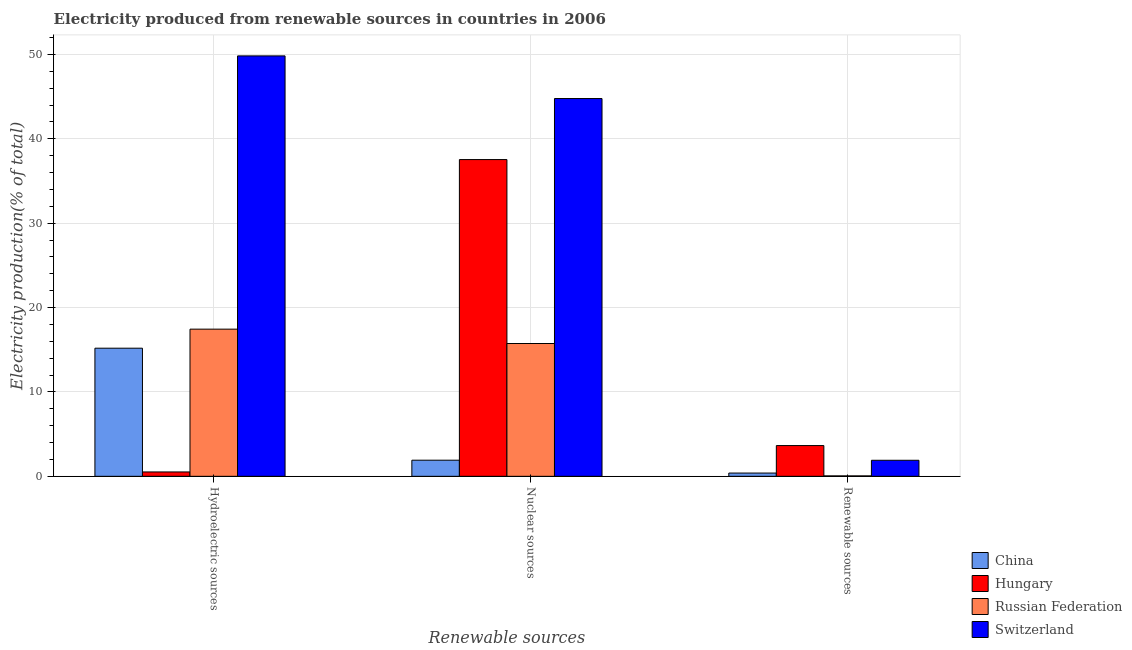How many groups of bars are there?
Keep it short and to the point. 3. Are the number of bars per tick equal to the number of legend labels?
Give a very brief answer. Yes. Are the number of bars on each tick of the X-axis equal?
Provide a short and direct response. Yes. How many bars are there on the 1st tick from the left?
Ensure brevity in your answer.  4. How many bars are there on the 3rd tick from the right?
Provide a succinct answer. 4. What is the label of the 1st group of bars from the left?
Give a very brief answer. Hydroelectric sources. What is the percentage of electricity produced by nuclear sources in Russian Federation?
Your answer should be very brief. 15.74. Across all countries, what is the maximum percentage of electricity produced by renewable sources?
Your answer should be very brief. 3.64. Across all countries, what is the minimum percentage of electricity produced by nuclear sources?
Keep it short and to the point. 1.91. In which country was the percentage of electricity produced by hydroelectric sources maximum?
Keep it short and to the point. Switzerland. In which country was the percentage of electricity produced by renewable sources minimum?
Make the answer very short. Russian Federation. What is the total percentage of electricity produced by nuclear sources in the graph?
Provide a succinct answer. 99.96. What is the difference between the percentage of electricity produced by renewable sources in Hungary and that in Russian Federation?
Provide a succinct answer. 3.59. What is the difference between the percentage of electricity produced by hydroelectric sources in Switzerland and the percentage of electricity produced by nuclear sources in Russian Federation?
Offer a very short reply. 34.09. What is the average percentage of electricity produced by hydroelectric sources per country?
Keep it short and to the point. 20.74. What is the difference between the percentage of electricity produced by nuclear sources and percentage of electricity produced by renewable sources in Hungary?
Make the answer very short. 33.89. In how many countries, is the percentage of electricity produced by renewable sources greater than 6 %?
Your answer should be compact. 0. What is the ratio of the percentage of electricity produced by renewable sources in Switzerland to that in China?
Your answer should be compact. 4.91. Is the percentage of electricity produced by nuclear sources in Switzerland less than that in Hungary?
Make the answer very short. No. What is the difference between the highest and the second highest percentage of electricity produced by hydroelectric sources?
Ensure brevity in your answer.  32.38. What is the difference between the highest and the lowest percentage of electricity produced by nuclear sources?
Ensure brevity in your answer.  42.86. In how many countries, is the percentage of electricity produced by renewable sources greater than the average percentage of electricity produced by renewable sources taken over all countries?
Provide a succinct answer. 2. What does the 2nd bar from the left in Nuclear sources represents?
Make the answer very short. Hungary. What does the 2nd bar from the right in Renewable sources represents?
Provide a succinct answer. Russian Federation. How many bars are there?
Offer a terse response. 12. Are all the bars in the graph horizontal?
Offer a very short reply. No. How many countries are there in the graph?
Provide a succinct answer. 4. What is the difference between two consecutive major ticks on the Y-axis?
Offer a very short reply. 10. Does the graph contain any zero values?
Make the answer very short. No. Does the graph contain grids?
Offer a very short reply. Yes. Where does the legend appear in the graph?
Keep it short and to the point. Bottom right. How many legend labels are there?
Make the answer very short. 4. How are the legend labels stacked?
Your answer should be very brief. Vertical. What is the title of the graph?
Your answer should be very brief. Electricity produced from renewable sources in countries in 2006. Does "Kuwait" appear as one of the legend labels in the graph?
Offer a terse response. No. What is the label or title of the X-axis?
Ensure brevity in your answer.  Renewable sources. What is the label or title of the Y-axis?
Give a very brief answer. Electricity production(% of total). What is the Electricity production(% of total) of China in Hydroelectric sources?
Ensure brevity in your answer.  15.19. What is the Electricity production(% of total) in Hungary in Hydroelectric sources?
Offer a very short reply. 0.52. What is the Electricity production(% of total) of Russian Federation in Hydroelectric sources?
Offer a very short reply. 17.44. What is the Electricity production(% of total) in Switzerland in Hydroelectric sources?
Keep it short and to the point. 49.83. What is the Electricity production(% of total) of China in Nuclear sources?
Your answer should be compact. 1.91. What is the Electricity production(% of total) of Hungary in Nuclear sources?
Offer a terse response. 37.54. What is the Electricity production(% of total) in Russian Federation in Nuclear sources?
Offer a very short reply. 15.74. What is the Electricity production(% of total) in Switzerland in Nuclear sources?
Give a very brief answer. 44.77. What is the Electricity production(% of total) of China in Renewable sources?
Give a very brief answer. 0.39. What is the Electricity production(% of total) in Hungary in Renewable sources?
Make the answer very short. 3.64. What is the Electricity production(% of total) of Russian Federation in Renewable sources?
Keep it short and to the point. 0.05. What is the Electricity production(% of total) in Switzerland in Renewable sources?
Provide a short and direct response. 1.9. Across all Renewable sources, what is the maximum Electricity production(% of total) of China?
Provide a succinct answer. 15.19. Across all Renewable sources, what is the maximum Electricity production(% of total) of Hungary?
Ensure brevity in your answer.  37.54. Across all Renewable sources, what is the maximum Electricity production(% of total) of Russian Federation?
Your answer should be very brief. 17.44. Across all Renewable sources, what is the maximum Electricity production(% of total) of Switzerland?
Your answer should be very brief. 49.83. Across all Renewable sources, what is the minimum Electricity production(% of total) of China?
Make the answer very short. 0.39. Across all Renewable sources, what is the minimum Electricity production(% of total) in Hungary?
Ensure brevity in your answer.  0.52. Across all Renewable sources, what is the minimum Electricity production(% of total) of Russian Federation?
Provide a succinct answer. 0.05. Across all Renewable sources, what is the minimum Electricity production(% of total) of Switzerland?
Your answer should be compact. 1.9. What is the total Electricity production(% of total) of China in the graph?
Your answer should be very brief. 17.48. What is the total Electricity production(% of total) of Hungary in the graph?
Offer a terse response. 41.7. What is the total Electricity production(% of total) in Russian Federation in the graph?
Offer a very short reply. 33.23. What is the total Electricity production(% of total) of Switzerland in the graph?
Provide a succinct answer. 96.5. What is the difference between the Electricity production(% of total) in China in Hydroelectric sources and that in Nuclear sources?
Offer a terse response. 13.27. What is the difference between the Electricity production(% of total) in Hungary in Hydroelectric sources and that in Nuclear sources?
Ensure brevity in your answer.  -37.02. What is the difference between the Electricity production(% of total) of Russian Federation in Hydroelectric sources and that in Nuclear sources?
Your answer should be very brief. 1.7. What is the difference between the Electricity production(% of total) in Switzerland in Hydroelectric sources and that in Nuclear sources?
Offer a very short reply. 5.05. What is the difference between the Electricity production(% of total) in China in Hydroelectric sources and that in Renewable sources?
Offer a terse response. 14.8. What is the difference between the Electricity production(% of total) of Hungary in Hydroelectric sources and that in Renewable sources?
Offer a terse response. -3.13. What is the difference between the Electricity production(% of total) in Russian Federation in Hydroelectric sources and that in Renewable sources?
Offer a very short reply. 17.39. What is the difference between the Electricity production(% of total) of Switzerland in Hydroelectric sources and that in Renewable sources?
Your answer should be very brief. 47.92. What is the difference between the Electricity production(% of total) in China in Nuclear sources and that in Renewable sources?
Provide a succinct answer. 1.52. What is the difference between the Electricity production(% of total) of Hungary in Nuclear sources and that in Renewable sources?
Give a very brief answer. 33.89. What is the difference between the Electricity production(% of total) in Russian Federation in Nuclear sources and that in Renewable sources?
Offer a terse response. 15.69. What is the difference between the Electricity production(% of total) of Switzerland in Nuclear sources and that in Renewable sources?
Offer a terse response. 42.87. What is the difference between the Electricity production(% of total) in China in Hydroelectric sources and the Electricity production(% of total) in Hungary in Nuclear sources?
Your answer should be very brief. -22.35. What is the difference between the Electricity production(% of total) of China in Hydroelectric sources and the Electricity production(% of total) of Russian Federation in Nuclear sources?
Keep it short and to the point. -0.56. What is the difference between the Electricity production(% of total) of China in Hydroelectric sources and the Electricity production(% of total) of Switzerland in Nuclear sources?
Provide a short and direct response. -29.59. What is the difference between the Electricity production(% of total) in Hungary in Hydroelectric sources and the Electricity production(% of total) in Russian Federation in Nuclear sources?
Your response must be concise. -15.22. What is the difference between the Electricity production(% of total) of Hungary in Hydroelectric sources and the Electricity production(% of total) of Switzerland in Nuclear sources?
Keep it short and to the point. -44.25. What is the difference between the Electricity production(% of total) in Russian Federation in Hydroelectric sources and the Electricity production(% of total) in Switzerland in Nuclear sources?
Ensure brevity in your answer.  -27.33. What is the difference between the Electricity production(% of total) in China in Hydroelectric sources and the Electricity production(% of total) in Hungary in Renewable sources?
Offer a very short reply. 11.54. What is the difference between the Electricity production(% of total) of China in Hydroelectric sources and the Electricity production(% of total) of Russian Federation in Renewable sources?
Keep it short and to the point. 15.13. What is the difference between the Electricity production(% of total) of China in Hydroelectric sources and the Electricity production(% of total) of Switzerland in Renewable sources?
Offer a very short reply. 13.28. What is the difference between the Electricity production(% of total) of Hungary in Hydroelectric sources and the Electricity production(% of total) of Russian Federation in Renewable sources?
Provide a succinct answer. 0.47. What is the difference between the Electricity production(% of total) of Hungary in Hydroelectric sources and the Electricity production(% of total) of Switzerland in Renewable sources?
Offer a terse response. -1.38. What is the difference between the Electricity production(% of total) of Russian Federation in Hydroelectric sources and the Electricity production(% of total) of Switzerland in Renewable sources?
Keep it short and to the point. 15.54. What is the difference between the Electricity production(% of total) in China in Nuclear sources and the Electricity production(% of total) in Hungary in Renewable sources?
Provide a succinct answer. -1.73. What is the difference between the Electricity production(% of total) in China in Nuclear sources and the Electricity production(% of total) in Russian Federation in Renewable sources?
Offer a very short reply. 1.86. What is the difference between the Electricity production(% of total) in China in Nuclear sources and the Electricity production(% of total) in Switzerland in Renewable sources?
Your answer should be compact. 0.01. What is the difference between the Electricity production(% of total) of Hungary in Nuclear sources and the Electricity production(% of total) of Russian Federation in Renewable sources?
Keep it short and to the point. 37.49. What is the difference between the Electricity production(% of total) of Hungary in Nuclear sources and the Electricity production(% of total) of Switzerland in Renewable sources?
Offer a very short reply. 35.64. What is the difference between the Electricity production(% of total) of Russian Federation in Nuclear sources and the Electricity production(% of total) of Switzerland in Renewable sources?
Your answer should be compact. 13.84. What is the average Electricity production(% of total) of China per Renewable sources?
Provide a succinct answer. 5.83. What is the average Electricity production(% of total) of Hungary per Renewable sources?
Provide a short and direct response. 13.9. What is the average Electricity production(% of total) of Russian Federation per Renewable sources?
Offer a terse response. 11.08. What is the average Electricity production(% of total) of Switzerland per Renewable sources?
Offer a terse response. 32.17. What is the difference between the Electricity production(% of total) in China and Electricity production(% of total) in Hungary in Hydroelectric sources?
Make the answer very short. 14.67. What is the difference between the Electricity production(% of total) in China and Electricity production(% of total) in Russian Federation in Hydroelectric sources?
Provide a succinct answer. -2.26. What is the difference between the Electricity production(% of total) in China and Electricity production(% of total) in Switzerland in Hydroelectric sources?
Offer a terse response. -34.64. What is the difference between the Electricity production(% of total) of Hungary and Electricity production(% of total) of Russian Federation in Hydroelectric sources?
Your response must be concise. -16.92. What is the difference between the Electricity production(% of total) of Hungary and Electricity production(% of total) of Switzerland in Hydroelectric sources?
Offer a terse response. -49.31. What is the difference between the Electricity production(% of total) of Russian Federation and Electricity production(% of total) of Switzerland in Hydroelectric sources?
Keep it short and to the point. -32.38. What is the difference between the Electricity production(% of total) in China and Electricity production(% of total) in Hungary in Nuclear sources?
Ensure brevity in your answer.  -35.63. What is the difference between the Electricity production(% of total) in China and Electricity production(% of total) in Russian Federation in Nuclear sources?
Offer a terse response. -13.83. What is the difference between the Electricity production(% of total) in China and Electricity production(% of total) in Switzerland in Nuclear sources?
Provide a succinct answer. -42.86. What is the difference between the Electricity production(% of total) of Hungary and Electricity production(% of total) of Russian Federation in Nuclear sources?
Make the answer very short. 21.8. What is the difference between the Electricity production(% of total) of Hungary and Electricity production(% of total) of Switzerland in Nuclear sources?
Provide a short and direct response. -7.23. What is the difference between the Electricity production(% of total) in Russian Federation and Electricity production(% of total) in Switzerland in Nuclear sources?
Your response must be concise. -29.03. What is the difference between the Electricity production(% of total) in China and Electricity production(% of total) in Hungary in Renewable sources?
Ensure brevity in your answer.  -3.26. What is the difference between the Electricity production(% of total) in China and Electricity production(% of total) in Russian Federation in Renewable sources?
Make the answer very short. 0.34. What is the difference between the Electricity production(% of total) in China and Electricity production(% of total) in Switzerland in Renewable sources?
Provide a short and direct response. -1.51. What is the difference between the Electricity production(% of total) of Hungary and Electricity production(% of total) of Russian Federation in Renewable sources?
Your answer should be compact. 3.59. What is the difference between the Electricity production(% of total) of Hungary and Electricity production(% of total) of Switzerland in Renewable sources?
Your response must be concise. 1.74. What is the difference between the Electricity production(% of total) of Russian Federation and Electricity production(% of total) of Switzerland in Renewable sources?
Your answer should be compact. -1.85. What is the ratio of the Electricity production(% of total) in China in Hydroelectric sources to that in Nuclear sources?
Make the answer very short. 7.95. What is the ratio of the Electricity production(% of total) of Hungary in Hydroelectric sources to that in Nuclear sources?
Give a very brief answer. 0.01. What is the ratio of the Electricity production(% of total) in Russian Federation in Hydroelectric sources to that in Nuclear sources?
Ensure brevity in your answer.  1.11. What is the ratio of the Electricity production(% of total) in Switzerland in Hydroelectric sources to that in Nuclear sources?
Offer a very short reply. 1.11. What is the ratio of the Electricity production(% of total) in China in Hydroelectric sources to that in Renewable sources?
Provide a short and direct response. 39.26. What is the ratio of the Electricity production(% of total) of Hungary in Hydroelectric sources to that in Renewable sources?
Offer a very short reply. 0.14. What is the ratio of the Electricity production(% of total) of Russian Federation in Hydroelectric sources to that in Renewable sources?
Keep it short and to the point. 338.58. What is the ratio of the Electricity production(% of total) in Switzerland in Hydroelectric sources to that in Renewable sources?
Offer a very short reply. 26.21. What is the ratio of the Electricity production(% of total) of China in Nuclear sources to that in Renewable sources?
Your response must be concise. 4.94. What is the ratio of the Electricity production(% of total) in Hungary in Nuclear sources to that in Renewable sources?
Your answer should be very brief. 10.3. What is the ratio of the Electricity production(% of total) of Russian Federation in Nuclear sources to that in Renewable sources?
Your answer should be compact. 305.54. What is the ratio of the Electricity production(% of total) of Switzerland in Nuclear sources to that in Renewable sources?
Keep it short and to the point. 23.56. What is the difference between the highest and the second highest Electricity production(% of total) of China?
Provide a short and direct response. 13.27. What is the difference between the highest and the second highest Electricity production(% of total) in Hungary?
Keep it short and to the point. 33.89. What is the difference between the highest and the second highest Electricity production(% of total) in Russian Federation?
Keep it short and to the point. 1.7. What is the difference between the highest and the second highest Electricity production(% of total) in Switzerland?
Ensure brevity in your answer.  5.05. What is the difference between the highest and the lowest Electricity production(% of total) in China?
Keep it short and to the point. 14.8. What is the difference between the highest and the lowest Electricity production(% of total) in Hungary?
Your answer should be very brief. 37.02. What is the difference between the highest and the lowest Electricity production(% of total) of Russian Federation?
Provide a short and direct response. 17.39. What is the difference between the highest and the lowest Electricity production(% of total) in Switzerland?
Offer a terse response. 47.92. 